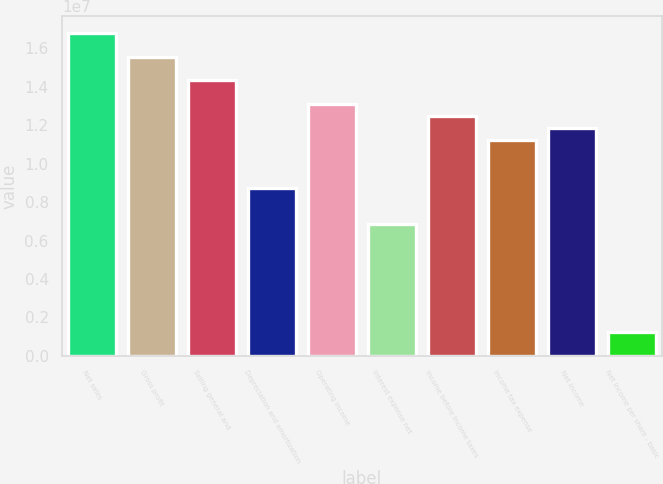Convert chart. <chart><loc_0><loc_0><loc_500><loc_500><bar_chart><fcel>Net sales<fcel>Gross profit<fcel>Selling general and<fcel>Depreciation and amortization<fcel>Operating income<fcel>Interest expense net<fcel>Income before income taxes<fcel>Income tax expense<fcel>Net income<fcel>Net income per share - basic<nl><fcel>1.68116e+07<fcel>1.55663e+07<fcel>1.4321e+07<fcel>8.71711e+06<fcel>1.30757e+07<fcel>6.84916e+06<fcel>1.2453e+07<fcel>1.12077e+07<fcel>1.18304e+07<fcel>1.2453e+06<nl></chart> 